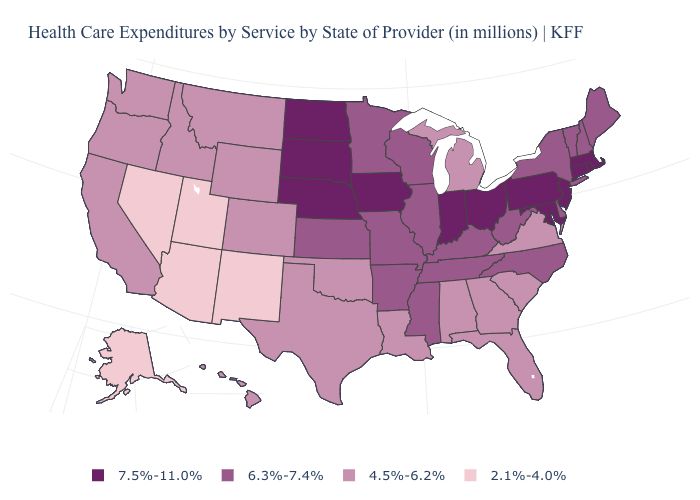Does Connecticut have the highest value in the USA?
Give a very brief answer. Yes. What is the value of Florida?
Quick response, please. 4.5%-6.2%. Name the states that have a value in the range 7.5%-11.0%?
Write a very short answer. Connecticut, Indiana, Iowa, Maryland, Massachusetts, Nebraska, New Jersey, North Dakota, Ohio, Pennsylvania, Rhode Island, South Dakota. Name the states that have a value in the range 7.5%-11.0%?
Concise answer only. Connecticut, Indiana, Iowa, Maryland, Massachusetts, Nebraska, New Jersey, North Dakota, Ohio, Pennsylvania, Rhode Island, South Dakota. Among the states that border Ohio , which have the lowest value?
Quick response, please. Michigan. Which states have the highest value in the USA?
Write a very short answer. Connecticut, Indiana, Iowa, Maryland, Massachusetts, Nebraska, New Jersey, North Dakota, Ohio, Pennsylvania, Rhode Island, South Dakota. What is the lowest value in the West?
Write a very short answer. 2.1%-4.0%. How many symbols are there in the legend?
Short answer required. 4. Among the states that border Connecticut , does New York have the lowest value?
Concise answer only. Yes. Among the states that border North Dakota , which have the lowest value?
Be succinct. Montana. What is the value of Maryland?
Quick response, please. 7.5%-11.0%. Name the states that have a value in the range 7.5%-11.0%?
Give a very brief answer. Connecticut, Indiana, Iowa, Maryland, Massachusetts, Nebraska, New Jersey, North Dakota, Ohio, Pennsylvania, Rhode Island, South Dakota. Name the states that have a value in the range 2.1%-4.0%?
Concise answer only. Alaska, Arizona, Nevada, New Mexico, Utah. Among the states that border Maryland , does Pennsylvania have the highest value?
Be succinct. Yes. Name the states that have a value in the range 4.5%-6.2%?
Be succinct. Alabama, California, Colorado, Florida, Georgia, Hawaii, Idaho, Louisiana, Michigan, Montana, Oklahoma, Oregon, South Carolina, Texas, Virginia, Washington, Wyoming. 